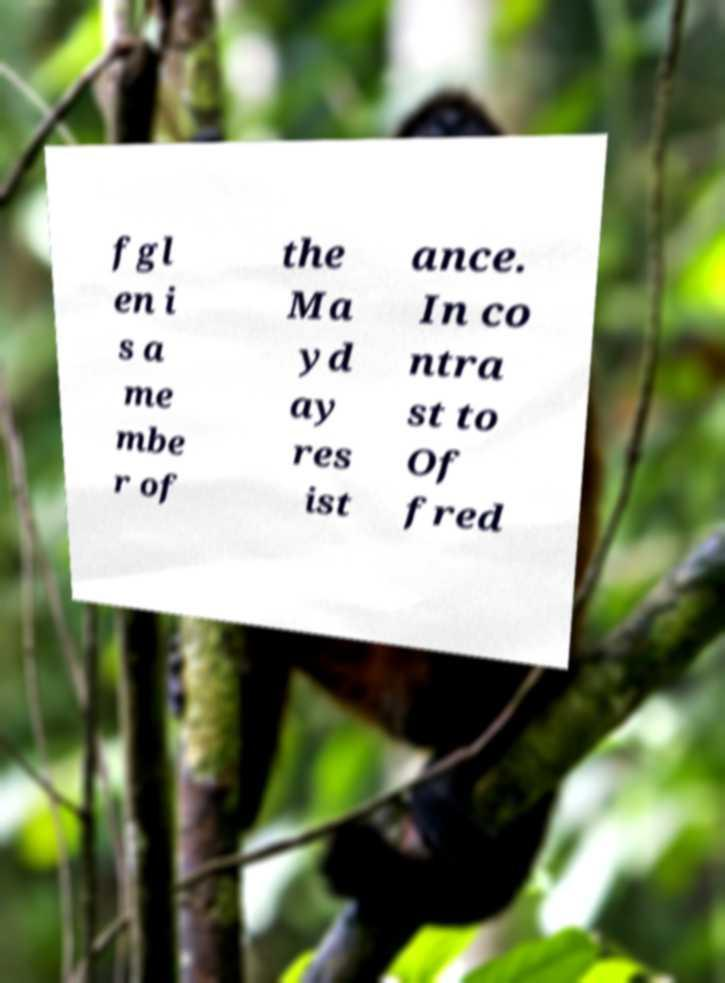Could you assist in decoding the text presented in this image and type it out clearly? fgl en i s a me mbe r of the Ma yd ay res ist ance. In co ntra st to Of fred 